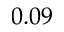Convert formula to latex. <formula><loc_0><loc_0><loc_500><loc_500>0 . 0 9</formula> 